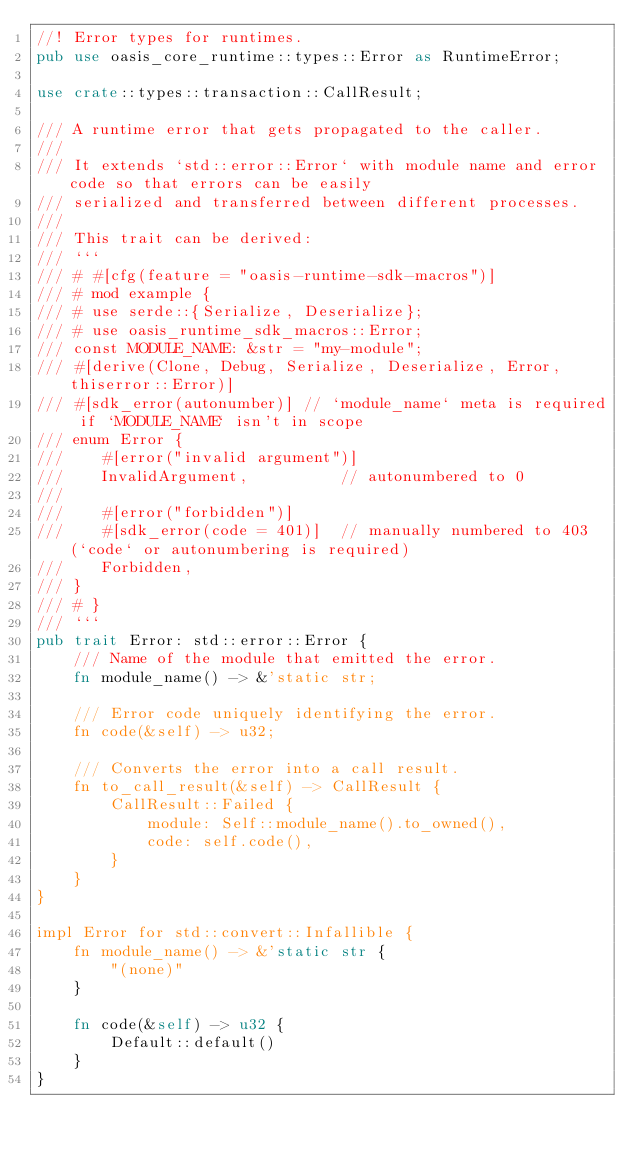<code> <loc_0><loc_0><loc_500><loc_500><_Rust_>//! Error types for runtimes.
pub use oasis_core_runtime::types::Error as RuntimeError;

use crate::types::transaction::CallResult;

/// A runtime error that gets propagated to the caller.
///
/// It extends `std::error::Error` with module name and error code so that errors can be easily
/// serialized and transferred between different processes.
///
/// This trait can be derived:
/// ```
/// # #[cfg(feature = "oasis-runtime-sdk-macros")]
/// # mod example {
/// # use serde::{Serialize, Deserialize};
/// # use oasis_runtime_sdk_macros::Error;
/// const MODULE_NAME: &str = "my-module";
/// #[derive(Clone, Debug, Serialize, Deserialize, Error, thiserror::Error)]
/// #[sdk_error(autonumber)] // `module_name` meta is required if `MODULE_NAME` isn't in scope
/// enum Error {
///    #[error("invalid argument")]
///    InvalidArgument,          // autonumbered to 0
///
///    #[error("forbidden")]
///    #[sdk_error(code = 401)]  // manually numbered to 403 (`code` or autonumbering is required)
///    Forbidden,
/// }
/// # }
/// ```
pub trait Error: std::error::Error {
    /// Name of the module that emitted the error.
    fn module_name() -> &'static str;

    /// Error code uniquely identifying the error.
    fn code(&self) -> u32;

    /// Converts the error into a call result.
    fn to_call_result(&self) -> CallResult {
        CallResult::Failed {
            module: Self::module_name().to_owned(),
            code: self.code(),
        }
    }
}

impl Error for std::convert::Infallible {
    fn module_name() -> &'static str {
        "(none)"
    }

    fn code(&self) -> u32 {
        Default::default()
    }
}
</code> 